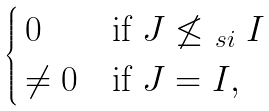Convert formula to latex. <formula><loc_0><loc_0><loc_500><loc_500>\begin{cases} \, 0 & \text {if} \ J \not \leq _ { \ s i } I \\ \, \ne 0 & \text {if} \ J = I , \end{cases}</formula> 